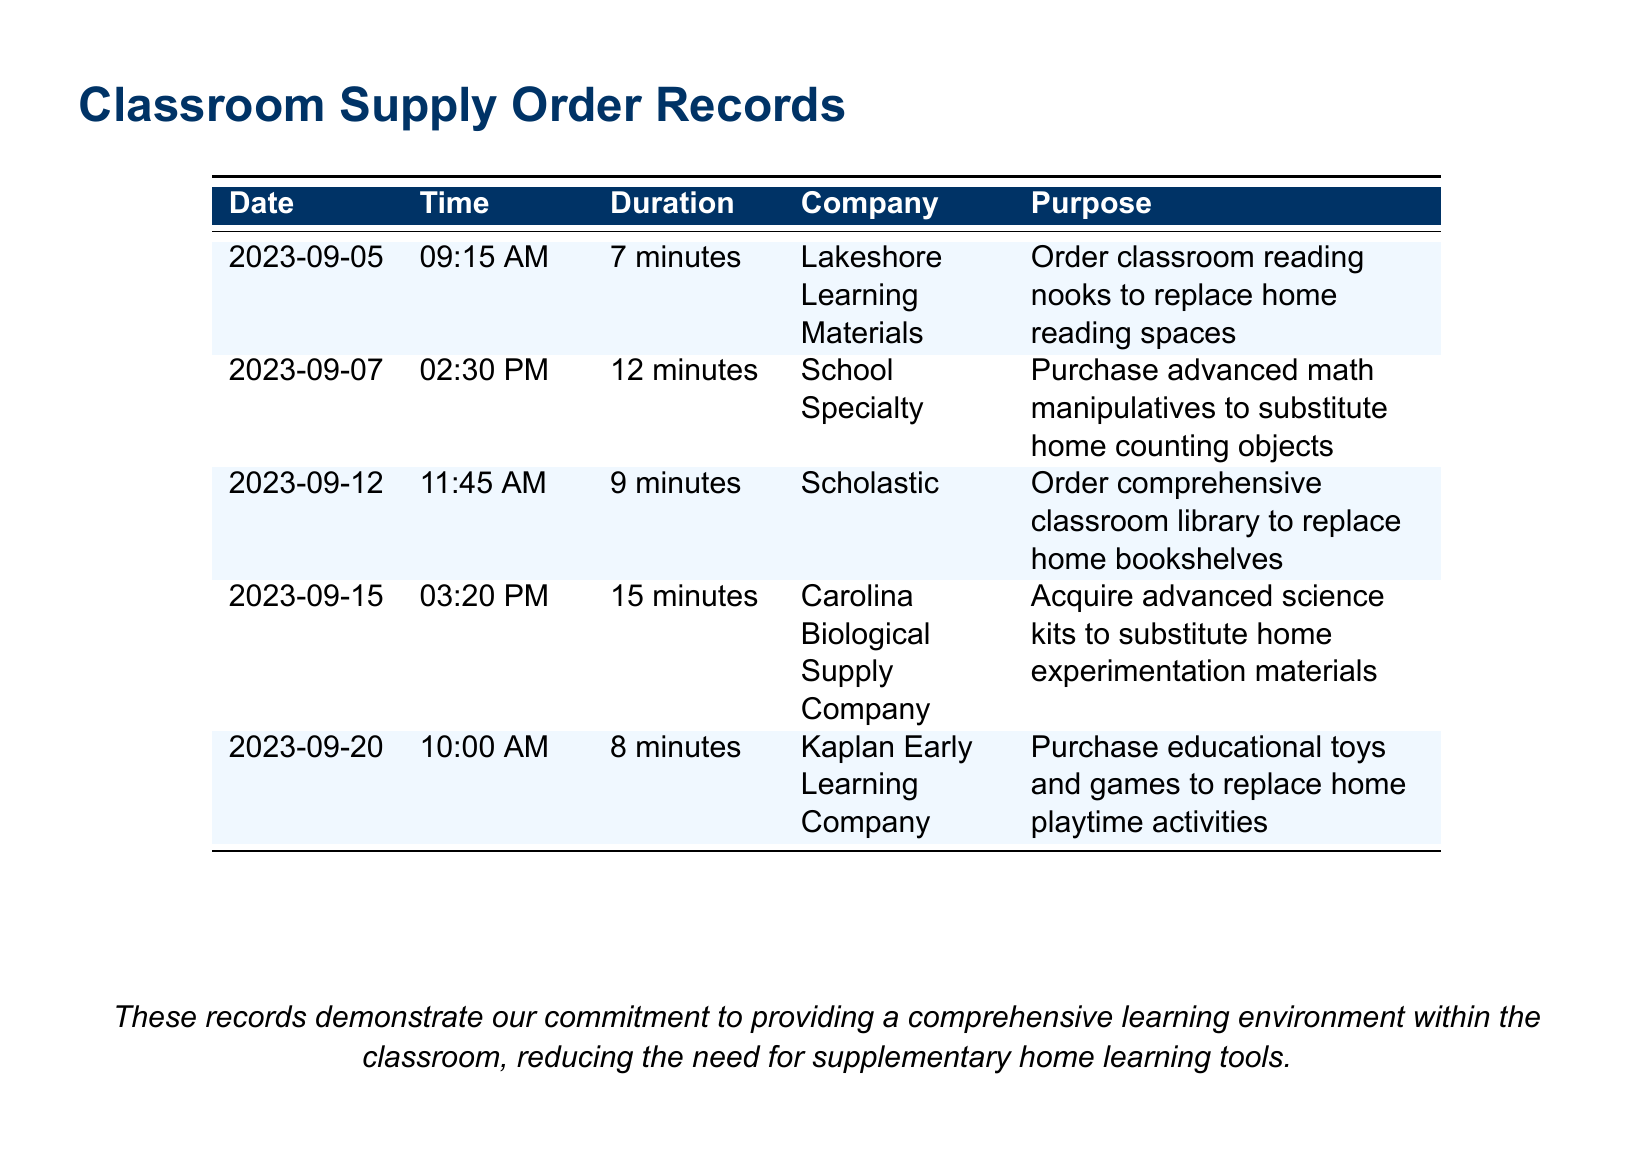what is the date of the first call? The first call listed in the document is on September 5, 2023.
Answer: September 5, 2023 who did the classroom supply order from on September 12, 2023? The order on this date was made to Scholastic.
Answer: Scholastic what item was ordered from Carolina Biological Supply Company? The order from this company was for advanced science kits.
Answer: advanced science kits how long was the call made to School Specialty? The call to this company lasted 12 minutes.
Answer: 12 minutes what is the purpose of the call made on September 20, 2023? The purpose was to purchase educational toys and games.
Answer: purchase educational toys and games which company was called to replace home bookshelves? The company called for this purpose was Scholastic.
Answer: Scholastic how many minutes did the longest call last? The longest call lasted 15 minutes.
Answer: 15 minutes what item is listed as a substitute for home reading spaces? The item ordered to replace home reading spaces is classroom reading nooks.
Answer: classroom reading nooks what date was the last call made? The last call in the document was made on September 20, 2023.
Answer: September 20, 2023 